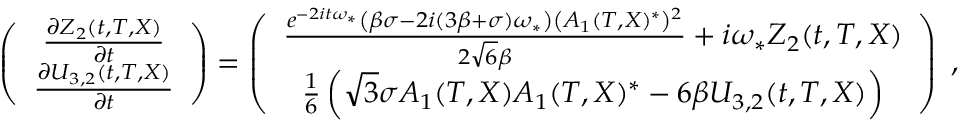<formula> <loc_0><loc_0><loc_500><loc_500>\begin{array} { r } { \left ( \begin{array} { c } { \frac { \partial Z _ { 2 } ( t , T , X ) } { \partial t } } \\ { \frac { \partial U _ { 3 , 2 } ( t , T , X ) } { \partial t } } \end{array} \right ) = \left ( \begin{array} { c } { \frac { e ^ { - 2 i t \omega _ { * } } \left ( \beta \sigma - 2 i ( 3 \beta + \sigma ) \omega _ { * } \right ) \left ( A _ { 1 } ( T , X ^ { * } \right ^ { 2 } } { 2 \sqrt { 6 } \beta } + i \omega _ { * } Z _ { 2 } ( t , T , X ) } \\ { \frac { 1 } { 6 } \left ( \sqrt { 3 } \sigma A _ { 1 } ( T , X ) A _ { 1 } ( T , X ^ { * } - 6 \beta U _ { 3 , 2 } ( t , T , X ) \right ) } \end{array} \right ) \, , } \end{array}</formula> 